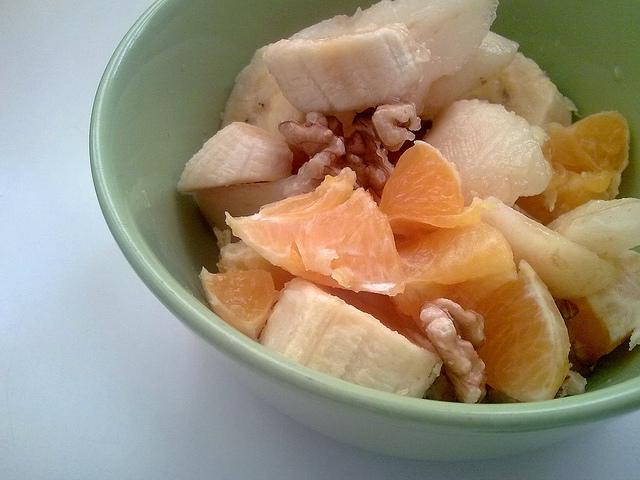Is the bowl orange?
Answer briefly. No. Is the fruit fresh?
Give a very brief answer. Yes. Is there a mix of fruit and nuts in this bowl?
Write a very short answer. Yes. Is the entire bowl in the frame?
Give a very brief answer. No. What color is the bowl?
Write a very short answer. Green. What is different about one of these oranges?
Answer briefly. It's grapefruit. Is the bowl metal?
Short answer required. No. 